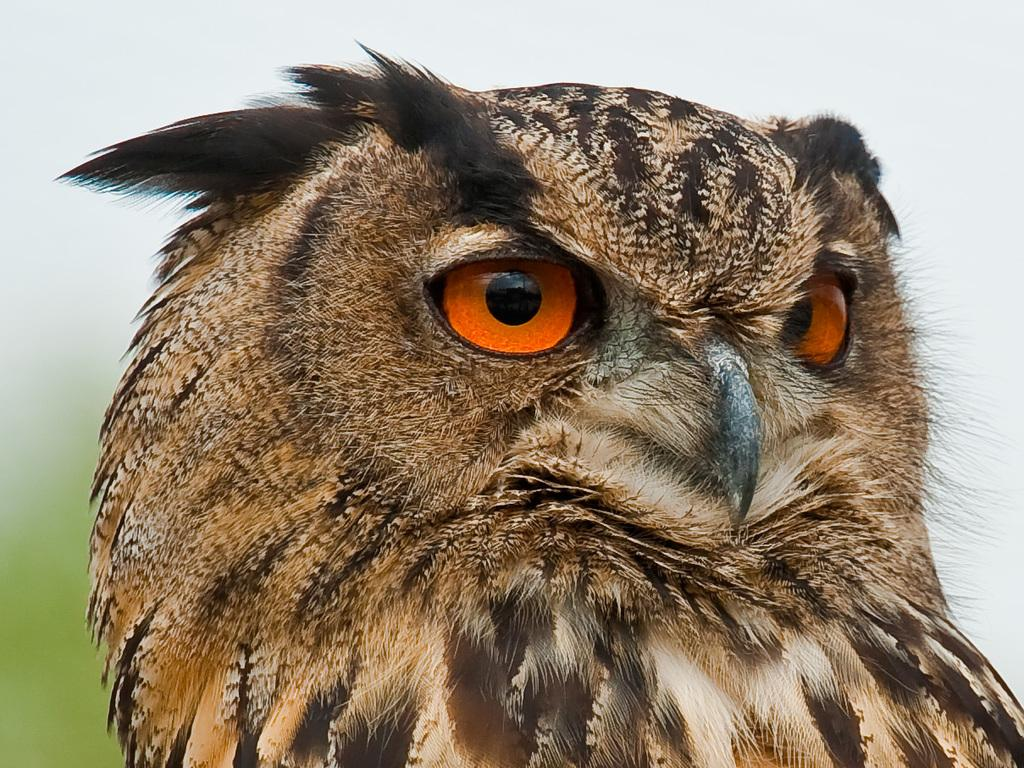What type of animal is in the image? There is an owl in the image. What color is the owl? The owl is brown in color. What facial features does the owl have? The owl has eyes and a beak. How many boats are visible in the image? There are no boats present in the image; it features an owl. What type of division is being performed by the owl in the image? The owl is not performing any division in the image; it is simply an animal with eyes and a beak. 